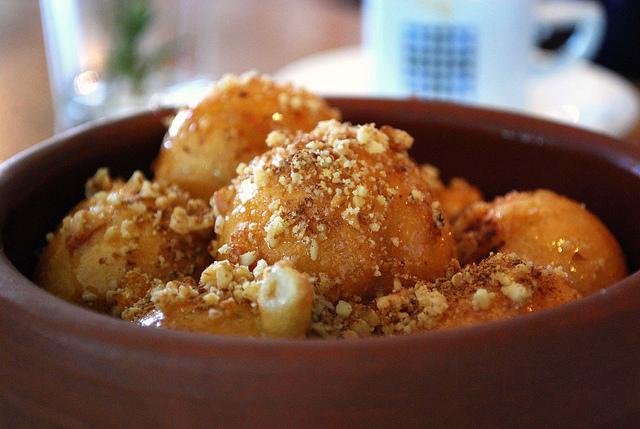Is this food in a bowl?
Quick response, please. Yes. How many cups are there?
Give a very brief answer. 2. Are there nuts in this dish?
Quick response, please. Yes. 